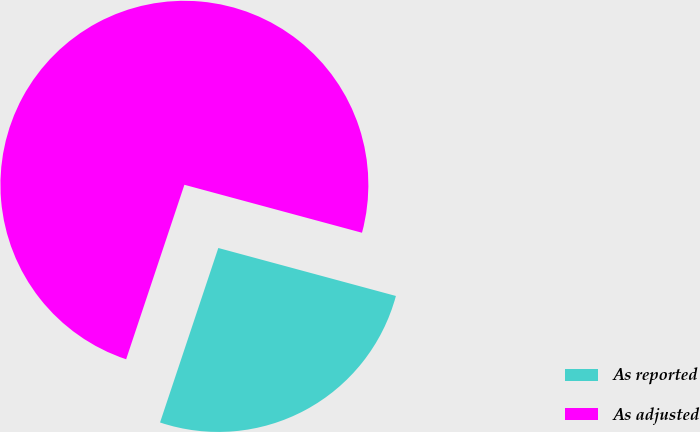<chart> <loc_0><loc_0><loc_500><loc_500><pie_chart><fcel>As reported<fcel>As adjusted<nl><fcel>25.93%<fcel>74.07%<nl></chart> 